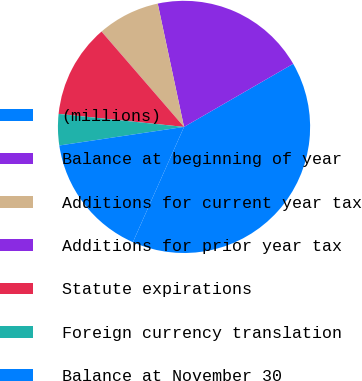Convert chart. <chart><loc_0><loc_0><loc_500><loc_500><pie_chart><fcel>(millions)<fcel>Balance at beginning of year<fcel>Additions for current year tax<fcel>Additions for prior year tax<fcel>Statute expirations<fcel>Foreign currency translation<fcel>Balance at November 30<nl><fcel>39.99%<fcel>20.0%<fcel>8.0%<fcel>0.01%<fcel>12.0%<fcel>4.0%<fcel>16.0%<nl></chart> 